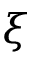Convert formula to latex. <formula><loc_0><loc_0><loc_500><loc_500>\xi</formula> 